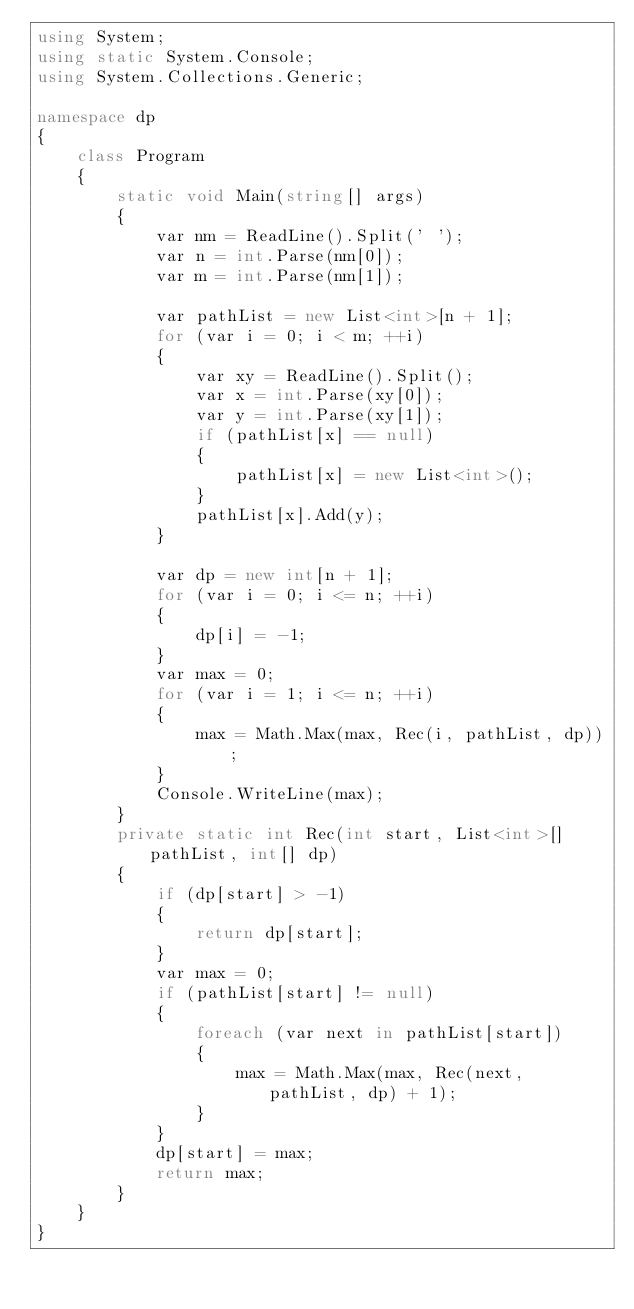<code> <loc_0><loc_0><loc_500><loc_500><_C#_>using System;
using static System.Console;
using System.Collections.Generic;

namespace dp
{
    class Program
    {
        static void Main(string[] args)
        {
            var nm = ReadLine().Split(' ');
            var n = int.Parse(nm[0]);
            var m = int.Parse(nm[1]);

            var pathList = new List<int>[n + 1];
            for (var i = 0; i < m; ++i)
            {
                var xy = ReadLine().Split();
                var x = int.Parse(xy[0]);
                var y = int.Parse(xy[1]);
                if (pathList[x] == null)
                {
                    pathList[x] = new List<int>();
                }
                pathList[x].Add(y);
            }

            var dp = new int[n + 1];
            for (var i = 0; i <= n; ++i)
            {
                dp[i] = -1;
            }
            var max = 0;
            for (var i = 1; i <= n; ++i)
            {
                max = Math.Max(max, Rec(i, pathList, dp));
            }
            Console.WriteLine(max);
        }
        private static int Rec(int start, List<int>[] pathList, int[] dp)
        {
            if (dp[start] > -1)
            {
                return dp[start];
            }
            var max = 0;
            if (pathList[start] != null)
            {
                foreach (var next in pathList[start])
                {
                    max = Math.Max(max, Rec(next, pathList, dp) + 1);
                }
            }
            dp[start] = max;
            return max;
        }
    }
}
</code> 